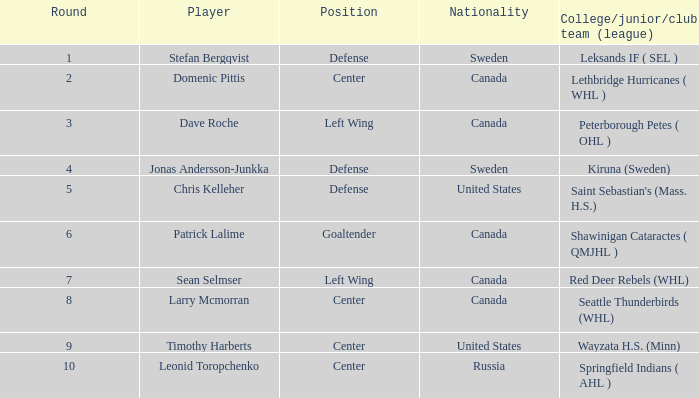What is the nationality of the player whose college/junior/club team (league) is Seattle Thunderbirds (WHL)? Canada. 